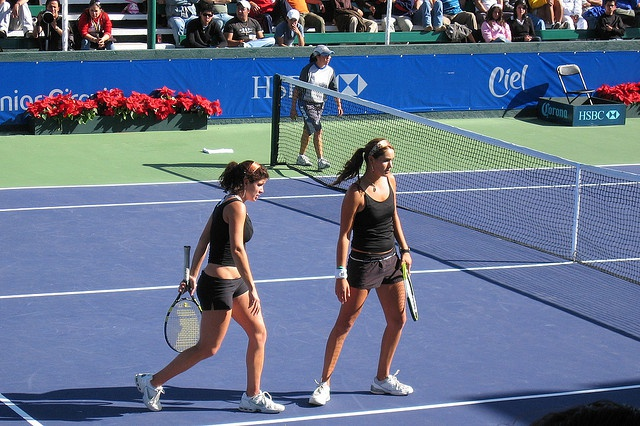Describe the objects in this image and their specific colors. I can see people in maroon, black, gray, and ivory tones, people in maroon, black, gray, and ivory tones, people in maroon, black, gray, white, and navy tones, potted plant in maroon, black, teal, and brown tones, and people in maroon, black, white, gray, and darkgray tones in this image. 